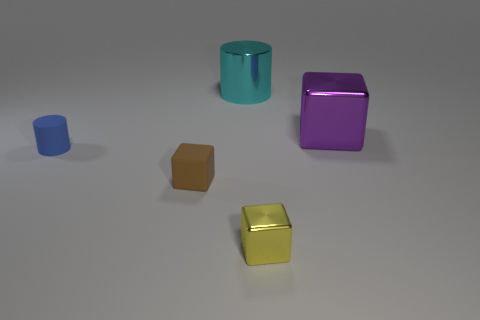What is the material of the cylinder on the right side of the blue thing?
Give a very brief answer. Metal. What is the size of the cylinder that is the same material as the large purple thing?
Your response must be concise. Large. What number of gray rubber things have the same shape as the yellow shiny thing?
Offer a terse response. 0. Do the small yellow object and the tiny matte thing right of the blue matte thing have the same shape?
Ensure brevity in your answer.  Yes. Is there a tiny gray cylinder that has the same material as the brown thing?
Make the answer very short. No. Is there anything else that is made of the same material as the small yellow thing?
Your response must be concise. Yes. What is the tiny object behind the small rubber thing to the right of the blue matte object made of?
Your answer should be compact. Rubber. There is a yellow cube in front of the big thing that is behind the large thing that is to the right of the shiny cylinder; how big is it?
Provide a succinct answer. Small. How many other things are the same shape as the small yellow thing?
Provide a succinct answer. 2. There is a big object that is right of the yellow shiny object; is its color the same as the cylinder on the left side of the cyan cylinder?
Provide a succinct answer. No. 